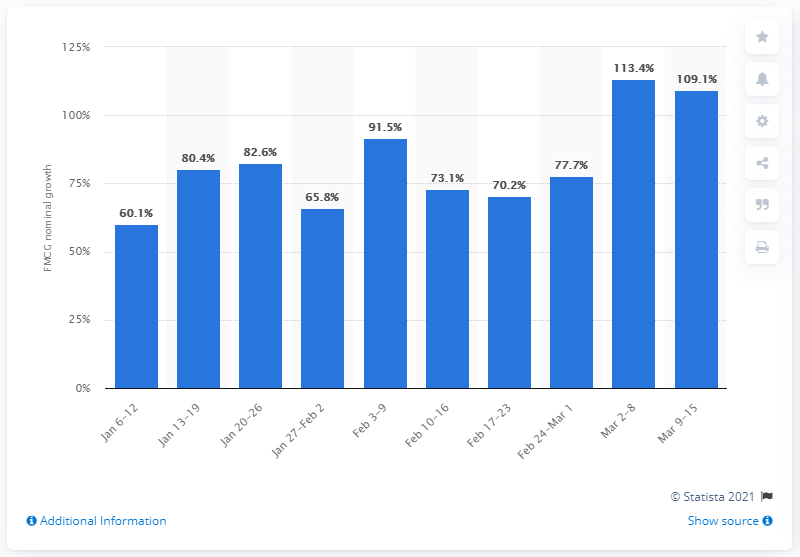Draw attention to some important aspects in this diagram. On March 9 to March 15, 2020, the nominal value of FMCG products sold through e-commerce in Russia was 109.1%. The nominal value of FMCG products sold through e-commerce in Russia from March 9 to March 15, 2020 was 109.1 million. 